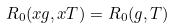<formula> <loc_0><loc_0><loc_500><loc_500>R _ { 0 } ( x g , x T ) = R _ { 0 } ( g , T )</formula> 